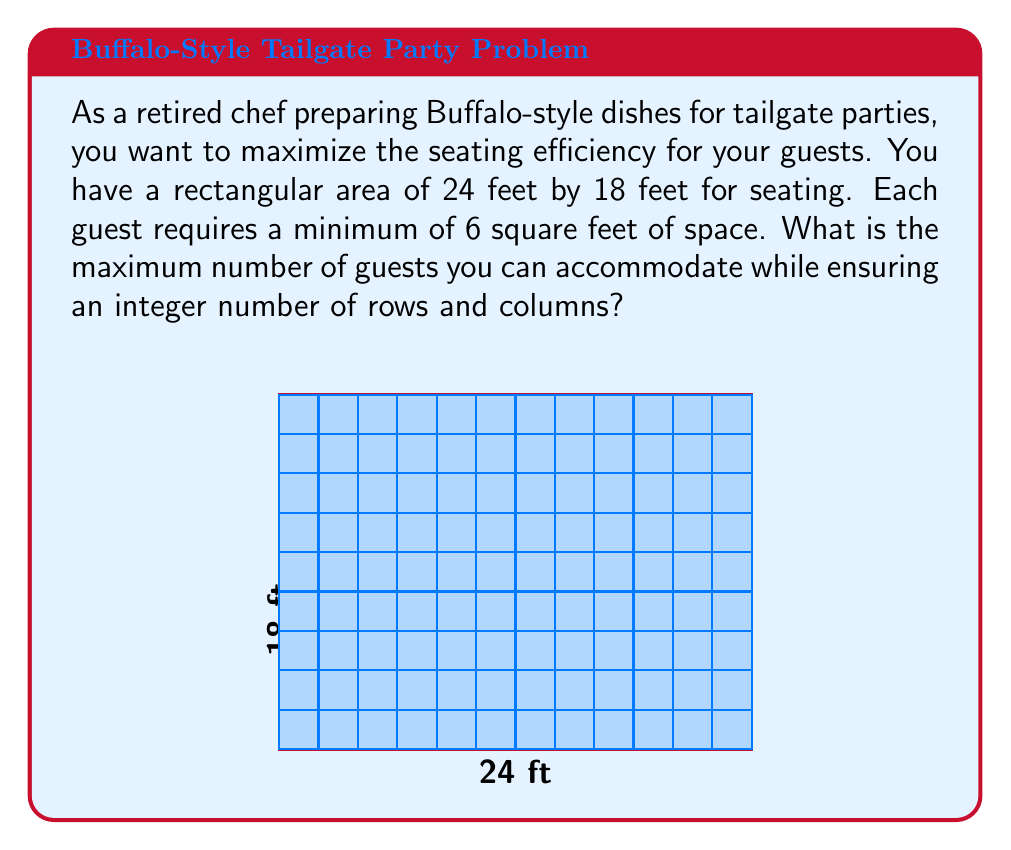Can you answer this question? Let's approach this step-by-step:

1) First, calculate the total area:
   $$ \text{Total Area} = 24 \text{ ft} \times 18 \text{ ft} = 432 \text{ sq ft} $$

2) Each guest requires 6 sq ft, so the theoretical maximum number of guests is:
   $$ \text{Theoretical Max} = \frac{432 \text{ sq ft}}{6 \text{ sq ft/guest}} = 72 \text{ guests} $$

3) However, we need to ensure an integer number of rows and columns. Let's consider factors of 72:
   $$ 72 = 1 \times 72 = 2 \times 36 = 3 \times 24 = 4 \times 18 = 6 \times 12 = 8 \times 9 $$

4) Now, we need to check which of these combinations fit within our 24 ft x 18 ft area:

   - 8 rows x 9 columns: $8 \times 3 \text{ ft} = 24 \text{ ft}$ and $9 \times 2 \text{ ft} = 18 \text{ ft}$

5) This arrangement works perfectly:
   - Each guest gets a 3 ft x 2 ft space (6 sq ft)
   - 8 rows fit in the 24 ft length
   - 9 columns fit in the 18 ft width

Therefore, the maximum number of guests while maintaining integer rows and columns is 72.
Answer: 72 guests 